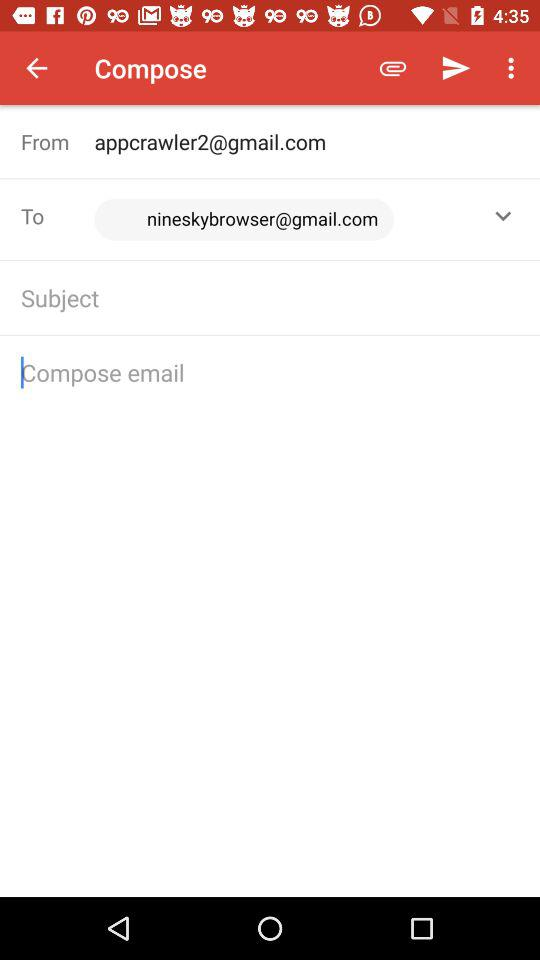What is the email address of the sender? The email address of the sender is appcrawler2@gmail.com. 